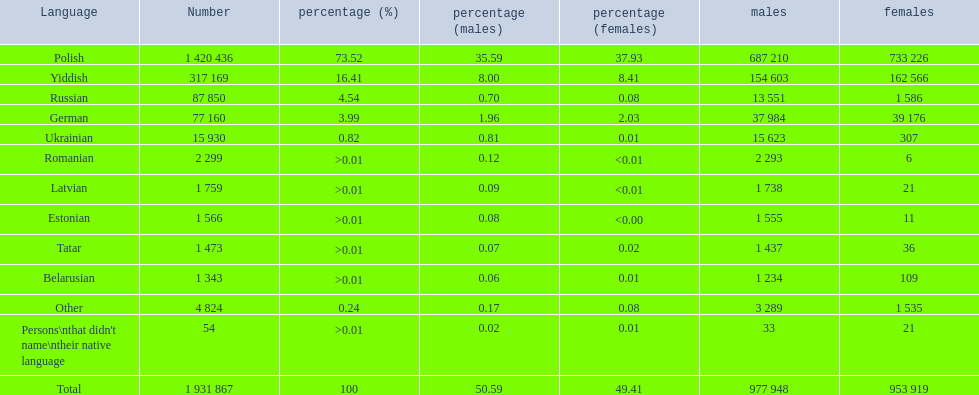How many languages are shown? Polish, Yiddish, Russian, German, Ukrainian, Romanian, Latvian, Estonian, Tatar, Belarusian, Other. What language is in third place? Russian. Parse the table in full. {'header': ['Language', 'Number', 'percentage (%)', 'percentage (males)', 'percentage (females)', 'males', 'females'], 'rows': [['Polish', '1 420 436', '73.52', '35.59', '37.93', '687 210', '733 226'], ['Yiddish', '317 169', '16.41', '8.00', '8.41', '154 603', '162 566'], ['Russian', '87 850', '4.54', '0.70', '0.08', '13 551', '1 586'], ['German', '77 160', '3.99', '1.96', '2.03', '37 984', '39 176'], ['Ukrainian', '15 930', '0.82', '0.81', '0.01', '15 623', '307'], ['Romanian', '2 299', '>0.01', '0.12', '<0.01', '2 293', '6'], ['Latvian', '1 759', '>0.01', '0.09', '<0.01', '1 738', '21'], ['Estonian', '1 566', '>0.01', '0.08', '<0.00', '1 555', '11'], ['Tatar', '1 473', '>0.01', '0.07', '0.02', '1 437', '36'], ['Belarusian', '1 343', '>0.01', '0.06', '0.01', '1 234', '109'], ['Other', '4 824', '0.24', '0.17', '0.08', '3 289', '1 535'], ["Persons\\nthat didn't name\\ntheir native language", '54', '>0.01', '0.02', '0.01', '33', '21'], ['Total', '1 931 867', '100', '50.59', '49.41', '977 948', '953 919']]} What language is the most spoken after that one? German. 